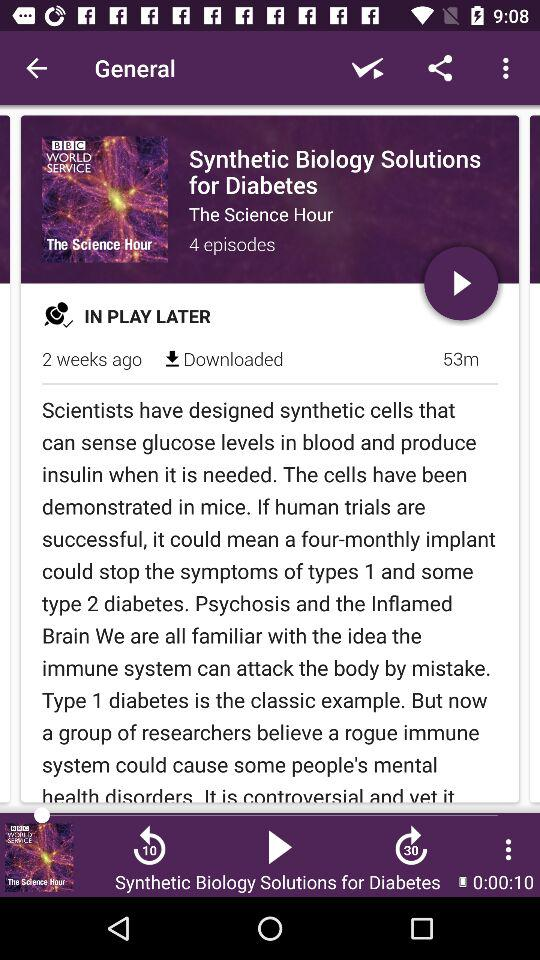What is the number of episodes in the "Synthetic Biology Solutions for Diabetes"? The number of episodes is 4. 